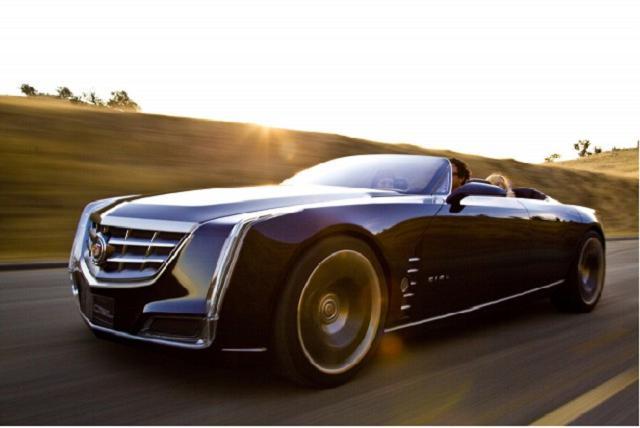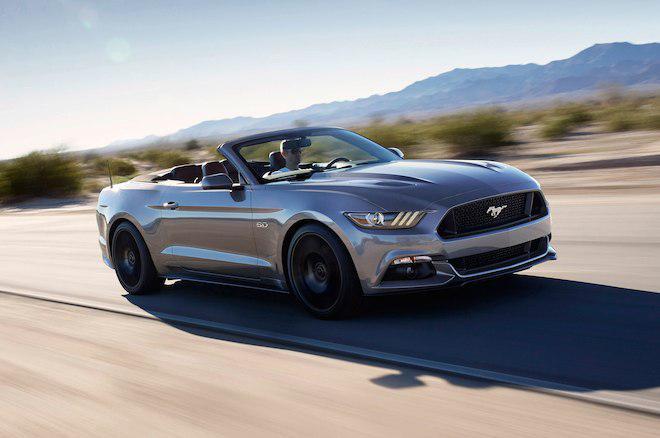The first image is the image on the left, the second image is the image on the right. Analyze the images presented: Is the assertion "Two convertibles of different makes and colors, with tops down, are being driven on open roads with no other visible traffic." valid? Answer yes or no. Yes. The first image is the image on the left, the second image is the image on the right. Considering the images on both sides, is "All cars are photographed with a blurry background as if they are moving." valid? Answer yes or no. Yes. 